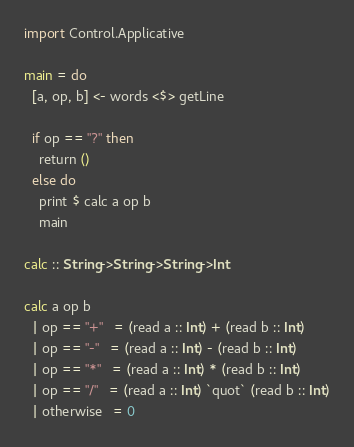<code> <loc_0><loc_0><loc_500><loc_500><_Haskell_>import Control.Applicative

main = do
  [a, op, b] <- words <$> getLine

  if op == "?" then
    return ()
  else do
    print $ calc a op b
    main

calc :: String->String->String->Int

calc a op b
  | op == "+"   = (read a :: Int) + (read b :: Int)
  | op == "-"   = (read a :: Int) - (read b :: Int)
  | op == "*"   = (read a :: Int) * (read b :: Int)
  | op == "/"   = (read a :: Int) `quot` (read b :: Int)
  | otherwise   = 0 </code> 